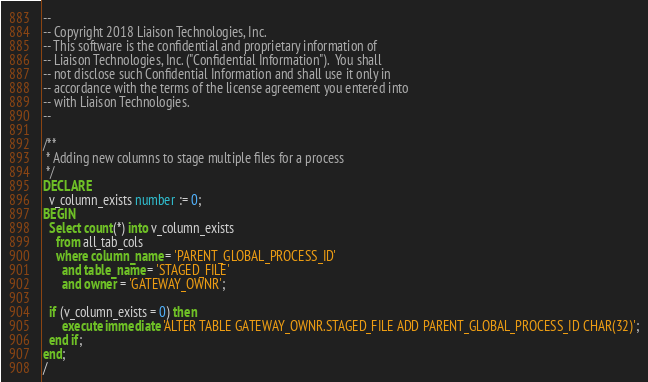Convert code to text. <code><loc_0><loc_0><loc_500><loc_500><_SQL_>--
-- Copyright 2018 Liaison Technologies, Inc.
-- This software is the confidential and proprietary information of
-- Liaison Technologies, Inc. ("Confidential Information").  You shall
-- not disclose such Confidential Information and shall use it only in
-- accordance with the terms of the license agreement you entered into
-- with Liaison Technologies.
--

/**
 * Adding new columns to stage multiple files for a process
 */
DECLARE
  v_column_exists number := 0;  
BEGIN
  Select count(*) into v_column_exists
    from all_tab_cols
    where column_name = 'PARENT_GLOBAL_PROCESS_ID'
      and table_name = 'STAGED_FILE'
      and owner = 'GATEWAY_OWNR';

  if (v_column_exists = 0) then
      execute immediate 'ALTER TABLE GATEWAY_OWNR.STAGED_FILE ADD PARENT_GLOBAL_PROCESS_ID CHAR(32)';
  end if;
end;
/</code> 